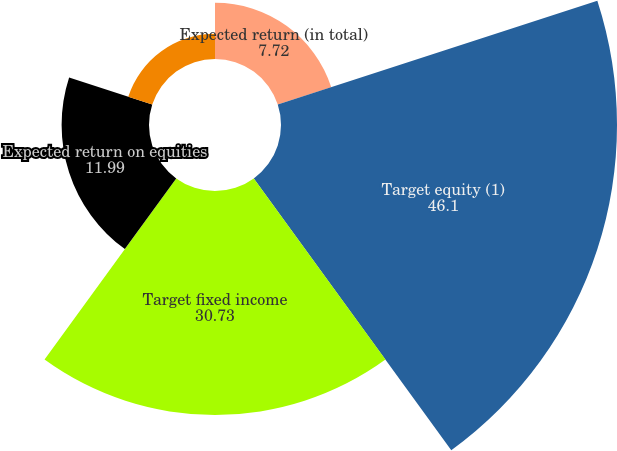Convert chart to OTSL. <chart><loc_0><loc_0><loc_500><loc_500><pie_chart><fcel>Expected return (in total)<fcel>Target equity (1)<fcel>Target fixed income<fcel>Expected return on equities<fcel>Expected return on fixed<nl><fcel>7.72%<fcel>46.1%<fcel>30.73%<fcel>11.99%<fcel>3.46%<nl></chart> 